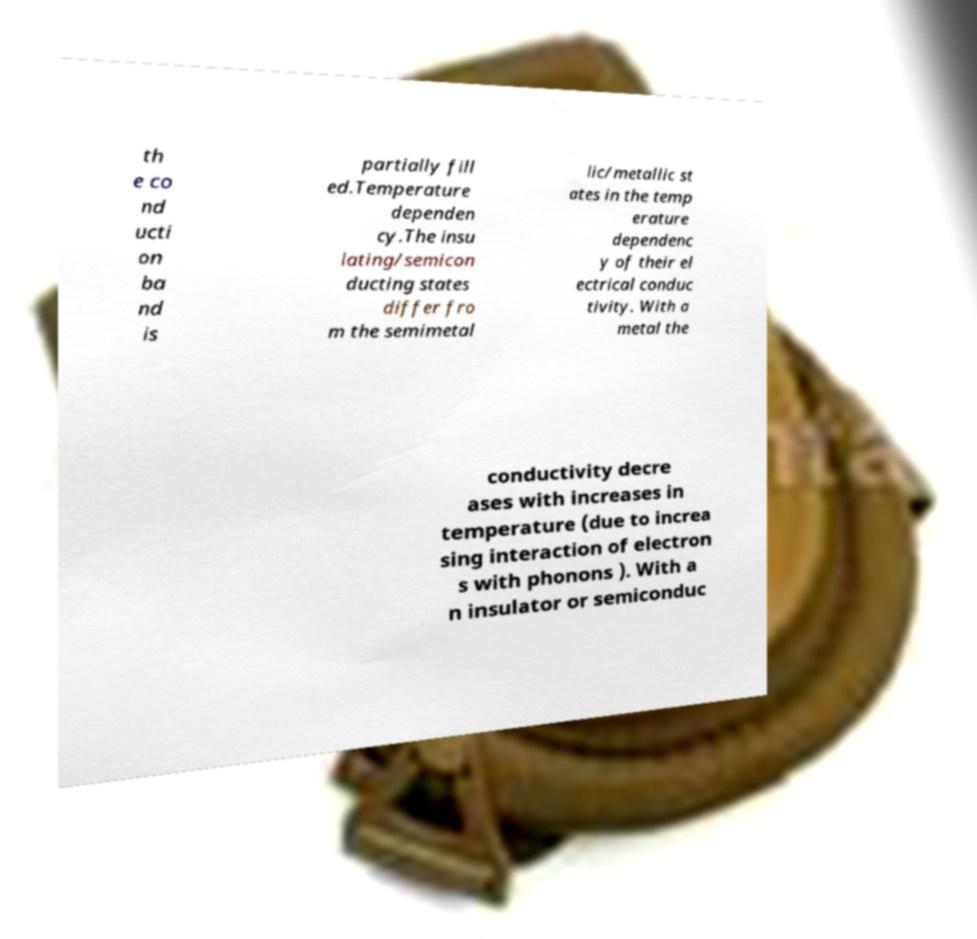I need the written content from this picture converted into text. Can you do that? th e co nd ucti on ba nd is partially fill ed.Temperature dependen cy.The insu lating/semicon ducting states differ fro m the semimetal lic/metallic st ates in the temp erature dependenc y of their el ectrical conduc tivity. With a metal the conductivity decre ases with increases in temperature (due to increa sing interaction of electron s with phonons ). With a n insulator or semiconduc 